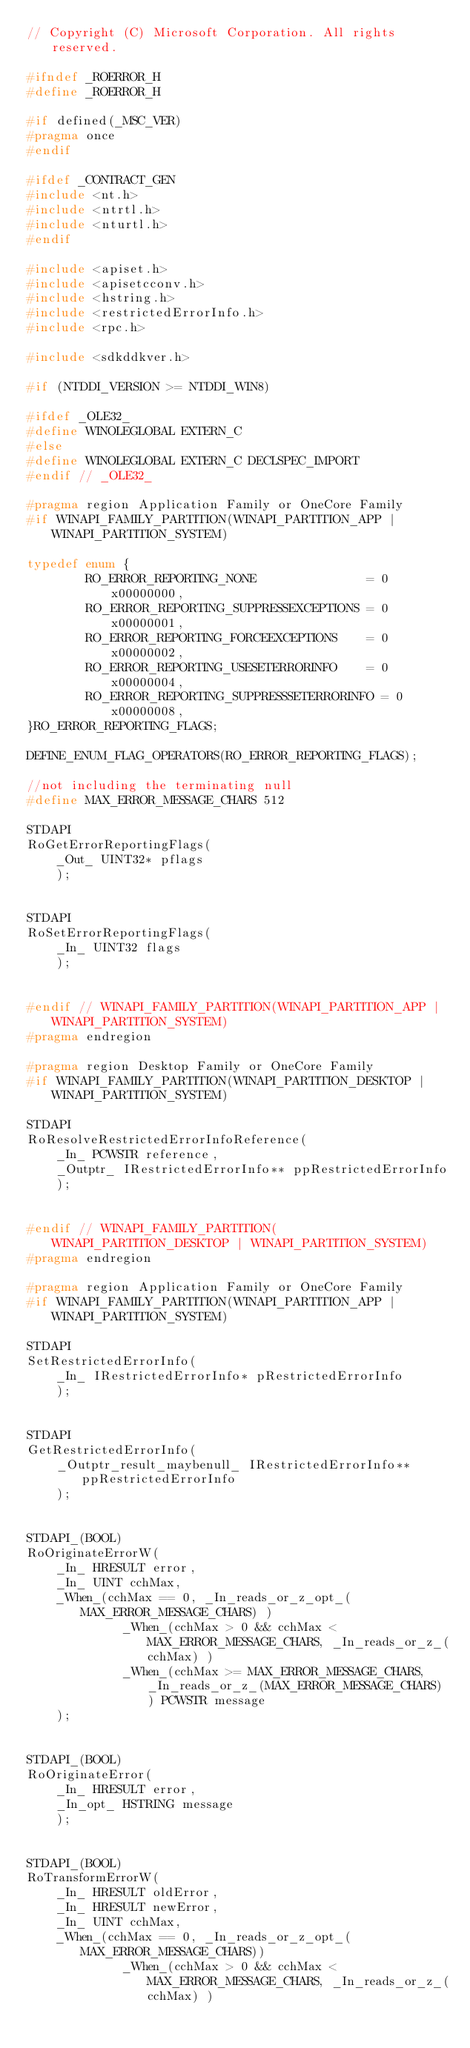<code> <loc_0><loc_0><loc_500><loc_500><_C_>// Copyright (C) Microsoft Corporation. All rights reserved.

#ifndef _ROERROR_H
#define _ROERROR_H

#if defined(_MSC_VER)
#pragma once
#endif

#ifdef _CONTRACT_GEN
#include <nt.h>
#include <ntrtl.h>
#include <nturtl.h>
#endif

#include <apiset.h>
#include <apisetcconv.h>
#include <hstring.h>
#include <restrictedErrorInfo.h>
#include <rpc.h>

#include <sdkddkver.h>

#if (NTDDI_VERSION >= NTDDI_WIN8)

#ifdef _OLE32_
#define WINOLEGLOBAL EXTERN_C 
#else
#define WINOLEGLOBAL EXTERN_C DECLSPEC_IMPORT
#endif // _OLE32_

#pragma region Application Family or OneCore Family
#if WINAPI_FAMILY_PARTITION(WINAPI_PARTITION_APP | WINAPI_PARTITION_SYSTEM)

typedef enum {
        RO_ERROR_REPORTING_NONE               = 0x00000000,
        RO_ERROR_REPORTING_SUPPRESSEXCEPTIONS = 0x00000001,
        RO_ERROR_REPORTING_FORCEEXCEPTIONS    = 0x00000002,
        RO_ERROR_REPORTING_USESETERRORINFO    = 0x00000004,
        RO_ERROR_REPORTING_SUPPRESSSETERRORINFO = 0x00000008,
}RO_ERROR_REPORTING_FLAGS;

DEFINE_ENUM_FLAG_OPERATORS(RO_ERROR_REPORTING_FLAGS);

//not including the terminating null
#define MAX_ERROR_MESSAGE_CHARS 512 

STDAPI
RoGetErrorReportingFlags(
    _Out_ UINT32* pflags
    );


STDAPI
RoSetErrorReportingFlags(
    _In_ UINT32 flags
    );


#endif // WINAPI_FAMILY_PARTITION(WINAPI_PARTITION_APP | WINAPI_PARTITION_SYSTEM)
#pragma endregion

#pragma region Desktop Family or OneCore Family
#if WINAPI_FAMILY_PARTITION(WINAPI_PARTITION_DESKTOP | WINAPI_PARTITION_SYSTEM)

STDAPI
RoResolveRestrictedErrorInfoReference(
    _In_ PCWSTR reference,
    _Outptr_ IRestrictedErrorInfo** ppRestrictedErrorInfo
    );

    
#endif // WINAPI_FAMILY_PARTITION(WINAPI_PARTITION_DESKTOP | WINAPI_PARTITION_SYSTEM)
#pragma endregion

#pragma region Application Family or OneCore Family
#if WINAPI_FAMILY_PARTITION(WINAPI_PARTITION_APP | WINAPI_PARTITION_SYSTEM)

STDAPI
SetRestrictedErrorInfo(
    _In_ IRestrictedErrorInfo* pRestrictedErrorInfo
    );


STDAPI
GetRestrictedErrorInfo(
    _Outptr_result_maybenull_ IRestrictedErrorInfo** ppRestrictedErrorInfo
    );


STDAPI_(BOOL)
RoOriginateErrorW(
    _In_ HRESULT error,
    _In_ UINT cchMax,
    _When_(cchMax == 0, _In_reads_or_z_opt_(MAX_ERROR_MESSAGE_CHARS) ) 
             _When_(cchMax > 0 && cchMax < MAX_ERROR_MESSAGE_CHARS, _In_reads_or_z_(cchMax) )
             _When_(cchMax >= MAX_ERROR_MESSAGE_CHARS, _In_reads_or_z_(MAX_ERROR_MESSAGE_CHARS) ) PCWSTR message
    );


STDAPI_(BOOL)
RoOriginateError(
    _In_ HRESULT error,
    _In_opt_ HSTRING message
    );


STDAPI_(BOOL)
RoTransformErrorW(
    _In_ HRESULT oldError,
    _In_ HRESULT newError,
    _In_ UINT cchMax,
    _When_(cchMax == 0, _In_reads_or_z_opt_(MAX_ERROR_MESSAGE_CHARS)) 
             _When_(cchMax > 0 && cchMax < MAX_ERROR_MESSAGE_CHARS, _In_reads_or_z_(cchMax) )</code> 